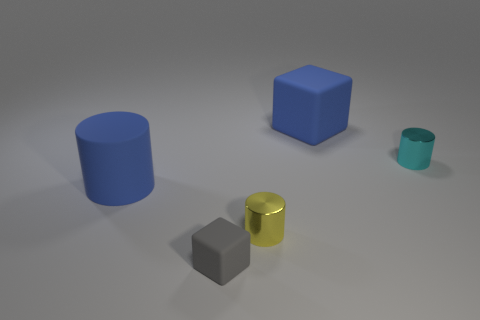Do the cyan thing and the blue matte object behind the small cyan metallic object have the same size?
Offer a very short reply. No. What number of cylinders are either small gray rubber things or tiny yellow shiny things?
Your answer should be very brief. 1. There is a block that is made of the same material as the small gray object; what size is it?
Offer a very short reply. Large. There is a shiny cylinder that is to the right of the big matte block; is it the same size as the blue object that is left of the blue block?
Your answer should be very brief. No. How many objects are either tiny red rubber cylinders or big rubber cubes?
Provide a succinct answer. 1. What shape is the tiny yellow metal object?
Provide a succinct answer. Cylinder. What size is the matte thing that is the same shape as the cyan metallic object?
Offer a very short reply. Large. There is a blue matte thing that is behind the tiny object to the right of the tiny yellow cylinder; what is its size?
Give a very brief answer. Large. Is the number of large blue blocks that are to the left of the big block the same as the number of large purple rubber things?
Offer a very short reply. Yes. What number of other objects are there of the same color as the rubber cylinder?
Provide a short and direct response. 1. 